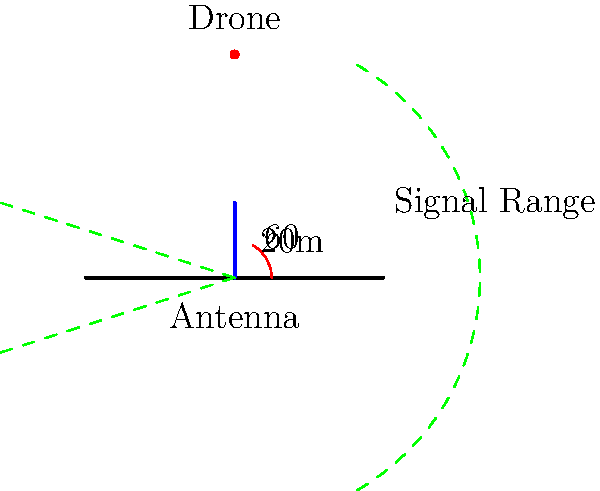As an avid tech enthusiast, you've just purchased a new drone from Amazon. The drone's manual states that its controller has a maximum signal range when the antenna is perfectly vertical. If the antenna is 20 meters tall and the maximum signal angle from the vertical is 60°, what is the approximate maximum range of the drone's signal on flat ground? (Assume the Earth's curvature is negligible for this distance.) Let's approach this step-by-step using trigonometry:

1) We can treat this as a right triangle problem, where:
   - The antenna height is the adjacent side (20 meters)
   - The signal range is the hypotenuse
   - The angle between these is 60°

2) In a right triangle, the cosine of an angle is the ratio of the adjacent side to the hypotenuse:

   $$\cos(60°) = \frac{\text{adjacent}}{\text{hypotenuse}} = \frac{20}{\text{range}}$$

3) We know that $\cos(60°) = \frac{1}{2}$, so we can substitute this:

   $$\frac{1}{2} = \frac{20}{\text{range}}$$

4) To solve for the range, we multiply both sides by 'range':

   $$\frac{1}{2} \cdot \text{range} = 20$$

5) Then multiply both sides by 2:

   $$\text{range} = 20 \cdot 2 = 40$$

Therefore, the maximum range of the drone's signal is approximately 40 meters.
Answer: 40 meters 